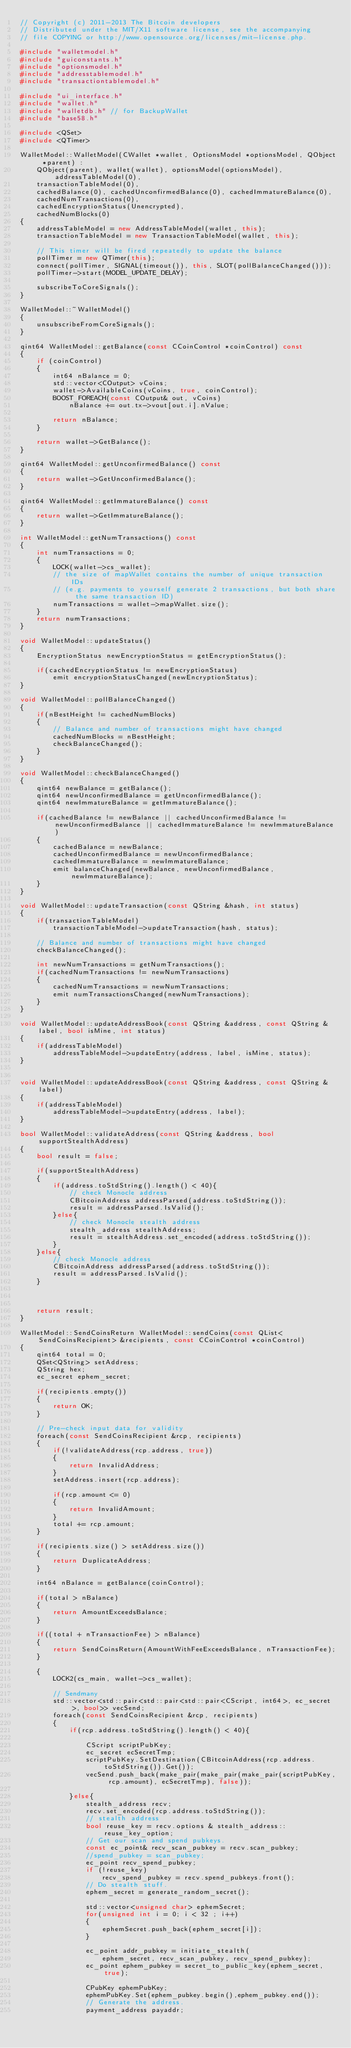Convert code to text. <code><loc_0><loc_0><loc_500><loc_500><_C++_>// Copyright (c) 2011-2013 The Bitcoin developers
// Distributed under the MIT/X11 software license, see the accompanying
// file COPYING or http://www.opensource.org/licenses/mit-license.php.

#include "walletmodel.h"
#include "guiconstants.h"
#include "optionsmodel.h"
#include "addresstablemodel.h"
#include "transactiontablemodel.h"

#include "ui_interface.h"
#include "wallet.h"
#include "walletdb.h" // for BackupWallet
#include "base58.h"

#include <QSet>
#include <QTimer>

WalletModel::WalletModel(CWallet *wallet, OptionsModel *optionsModel, QObject *parent) :
    QObject(parent), wallet(wallet), optionsModel(optionsModel), addressTableModel(0),
    transactionTableModel(0),
    cachedBalance(0), cachedUnconfirmedBalance(0), cachedImmatureBalance(0),
    cachedNumTransactions(0),
    cachedEncryptionStatus(Unencrypted),
    cachedNumBlocks(0)
{
    addressTableModel = new AddressTableModel(wallet, this);
    transactionTableModel = new TransactionTableModel(wallet, this);

    // This timer will be fired repeatedly to update the balance
    pollTimer = new QTimer(this);
    connect(pollTimer, SIGNAL(timeout()), this, SLOT(pollBalanceChanged()));
    pollTimer->start(MODEL_UPDATE_DELAY);

    subscribeToCoreSignals();
}

WalletModel::~WalletModel()
{
    unsubscribeFromCoreSignals();
}

qint64 WalletModel::getBalance(const CCoinControl *coinControl) const
{
    if (coinControl)
    {
        int64 nBalance = 0;
        std::vector<COutput> vCoins;
        wallet->AvailableCoins(vCoins, true, coinControl);
        BOOST_FOREACH(const COutput& out, vCoins)
            nBalance += out.tx->vout[out.i].nValue;   
        
        return nBalance;
    }
    
    return wallet->GetBalance();
}

qint64 WalletModel::getUnconfirmedBalance() const
{
    return wallet->GetUnconfirmedBalance();
}

qint64 WalletModel::getImmatureBalance() const
{
    return wallet->GetImmatureBalance();
}

int WalletModel::getNumTransactions() const
{
    int numTransactions = 0;
    {
        LOCK(wallet->cs_wallet);
        // the size of mapWallet contains the number of unique transaction IDs
        // (e.g. payments to yourself generate 2 transactions, but both share the same transaction ID)
        numTransactions = wallet->mapWallet.size();
    }
    return numTransactions;
}

void WalletModel::updateStatus()
{
    EncryptionStatus newEncryptionStatus = getEncryptionStatus();

    if(cachedEncryptionStatus != newEncryptionStatus)
        emit encryptionStatusChanged(newEncryptionStatus);
}

void WalletModel::pollBalanceChanged()
{
    if(nBestHeight != cachedNumBlocks)
    {
        // Balance and number of transactions might have changed
        cachedNumBlocks = nBestHeight;
        checkBalanceChanged();
    }
}

void WalletModel::checkBalanceChanged()
{
    qint64 newBalance = getBalance();
    qint64 newUnconfirmedBalance = getUnconfirmedBalance();
    qint64 newImmatureBalance = getImmatureBalance();

    if(cachedBalance != newBalance || cachedUnconfirmedBalance != newUnconfirmedBalance || cachedImmatureBalance != newImmatureBalance)
    {
        cachedBalance = newBalance;
        cachedUnconfirmedBalance = newUnconfirmedBalance;
        cachedImmatureBalance = newImmatureBalance;
        emit balanceChanged(newBalance, newUnconfirmedBalance, newImmatureBalance);
    }
}

void WalletModel::updateTransaction(const QString &hash, int status)
{
    if(transactionTableModel)
        transactionTableModel->updateTransaction(hash, status);

    // Balance and number of transactions might have changed
    checkBalanceChanged();

    int newNumTransactions = getNumTransactions();
    if(cachedNumTransactions != newNumTransactions)
    {
        cachedNumTransactions = newNumTransactions;
        emit numTransactionsChanged(newNumTransactions);
    }
}

void WalletModel::updateAddressBook(const QString &address, const QString &label, bool isMine, int status)
{
    if(addressTableModel)
        addressTableModel->updateEntry(address, label, isMine, status);
}


void WalletModel::updateAddressBook(const QString &address, const QString &label)
{
    if(addressTableModel)
        addressTableModel->updateEntry(address, label);
}

bool WalletModel::validateAddress(const QString &address, bool supportStealthAddress)
{
    bool result = false;

    if(supportStealthAddress)
    {
        if(address.toStdString().length() < 40){
            // check Monocle address
            CBitcoinAddress addressParsed(address.toStdString());
            result = addressParsed.IsValid();
        }else{
            // check Monocle stealth address
            stealth_address stealthAddress;
            result = stealthAddress.set_encoded(address.toStdString());
        }
    }else{
        // check Monocle address
        CBitcoinAddress addressParsed(address.toStdString());
        result = addressParsed.IsValid();
    }



    return result;
}

WalletModel::SendCoinsReturn WalletModel::sendCoins(const QList<SendCoinsRecipient> &recipients, const CCoinControl *coinControl)
{
    qint64 total = 0;
    QSet<QString> setAddress;
    QString hex;
    ec_secret ephem_secret;

    if(recipients.empty())
    {
        return OK;
    }

    // Pre-check input data for validity
    foreach(const SendCoinsRecipient &rcp, recipients)
    {
        if(!validateAddress(rcp.address, true))
        {
            return InvalidAddress;
        }
        setAddress.insert(rcp.address);

        if(rcp.amount <= 0)
        {
            return InvalidAmount;
        }
        total += rcp.amount;
    }

    if(recipients.size() > setAddress.size())
    {
        return DuplicateAddress;
    }

    int64 nBalance = getBalance(coinControl);

    if(total > nBalance)
    {
        return AmountExceedsBalance;
    }

    if((total + nTransactionFee) > nBalance)
    {
        return SendCoinsReturn(AmountWithFeeExceedsBalance, nTransactionFee);
    }

    {
        LOCK2(cs_main, wallet->cs_wallet);

        // Sendmany
        std::vector<std::pair<std::pair<std::pair<CScript, int64>, ec_secret>, bool>> vecSend;
        foreach(const SendCoinsRecipient &rcp, recipients)
        {
            if(rcp.address.toStdString().length() < 40){

                CScript scriptPubKey;
                ec_secret ecSecretTmp;
                scriptPubKey.SetDestination(CBitcoinAddress(rcp.address.toStdString()).Get());
                vecSend.push_back(make_pair(make_pair(make_pair(scriptPubKey, rcp.amount), ecSecretTmp), false));

            }else{
                stealth_address recv;
                recv.set_encoded(rcp.address.toStdString());
                // stealth address
                bool reuse_key = recv.options & stealth_address::reuse_key_option;
                // Get our scan and spend pubkeys.
                const ec_point& recv_scan_pubkey = recv.scan_pubkey;
                //spend_pubkey = scan_pubkey;
                ec_point recv_spend_pubkey;
                if (!reuse_key)
                    recv_spend_pubkey = recv.spend_pubkeys.front();
                // Do stealth stuff.
                ephem_secret = generate_random_secret();

                std::vector<unsigned char> ephemSecret;
                for(unsigned int i = 0; i < 32 ; i++)
                {
                    ephemSecret.push_back(ephem_secret[i]);
                }

                ec_point addr_pubkey = initiate_stealth(
                    ephem_secret, recv_scan_pubkey, recv_spend_pubkey);
                ec_point ephem_pubkey = secret_to_public_key(ephem_secret, true);

                CPubKey ephemPubKey;
                ephemPubKey.Set(ephem_pubkey.begin(),ephem_pubkey.end());
                // Generate the address.
                payment_address payaddr;</code> 